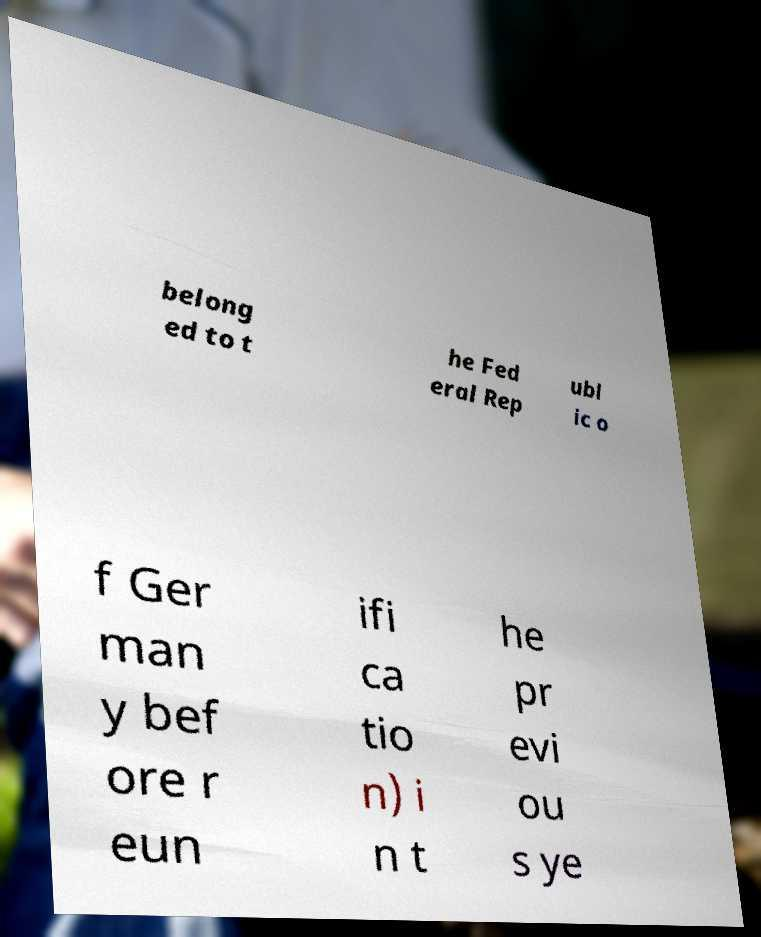Can you read and provide the text displayed in the image?This photo seems to have some interesting text. Can you extract and type it out for me? belong ed to t he Fed eral Rep ubl ic o f Ger man y bef ore r eun ifi ca tio n) i n t he pr evi ou s ye 